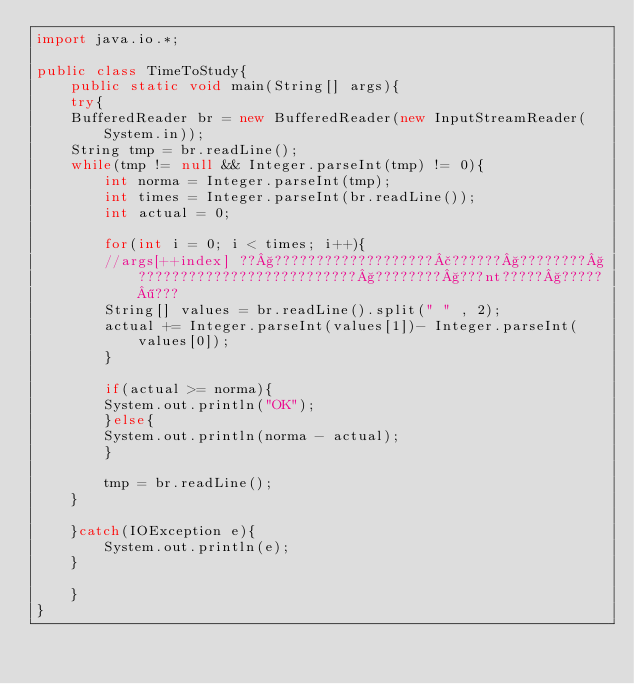<code> <loc_0><loc_0><loc_500><loc_500><_Java_>import java.io.*;

public class TimeToStudy{
    public static void main(String[] args){
	try{
	BufferedReader br = new BufferedReader(new InputStreamReader(System.in));
	String tmp = br.readLine();
	while(tmp != null && Integer.parseInt(tmp) != 0){
	    int norma = Integer.parseInt(tmp);
	    int times = Integer.parseInt(br.readLine());
	    int actual = 0;
	    
	    for(int i = 0; i < times; i++){
		//args[++index] ??§???????????????????£??????§????????§??????????????????????????§????????§???nt?????§?????¶???
		String[] values = br.readLine().split(" " , 2);
		actual += Integer.parseInt(values[1])- Integer.parseInt(values[0]);
	    }

	    if(actual >= norma){
		System.out.println("OK");
	    }else{
		System.out.println(norma - actual);
	    }

	    tmp = br.readLine();
	}

	}catch(IOException e){
	    System.out.println(e);
	}
	
    }
}</code> 